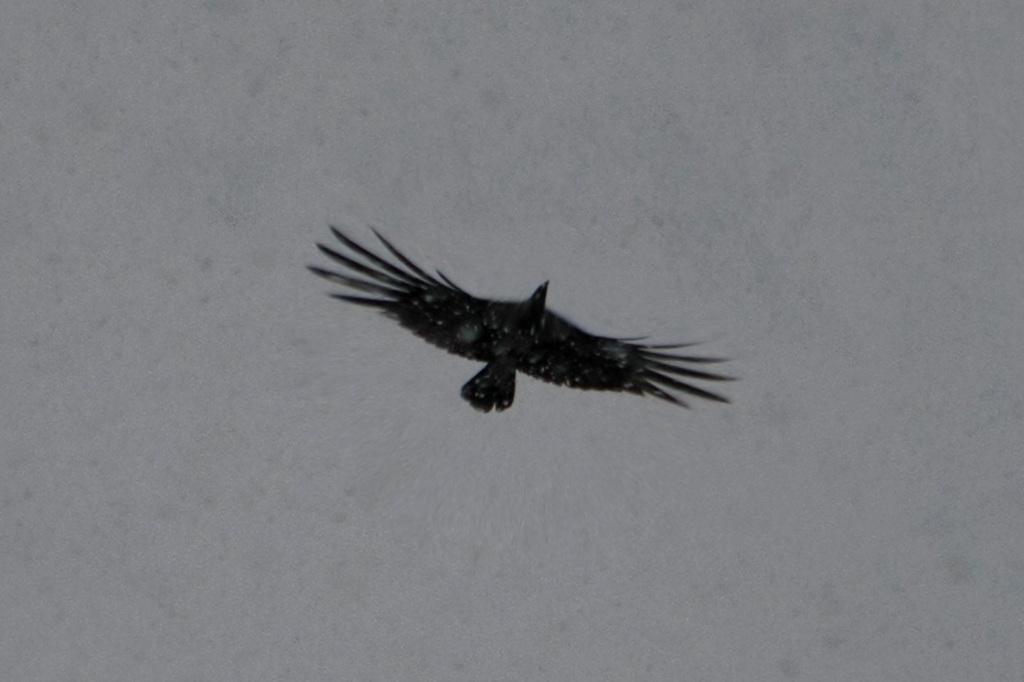How would you summarize this image in a sentence or two? In this image we can see a bird flying in the sky. 